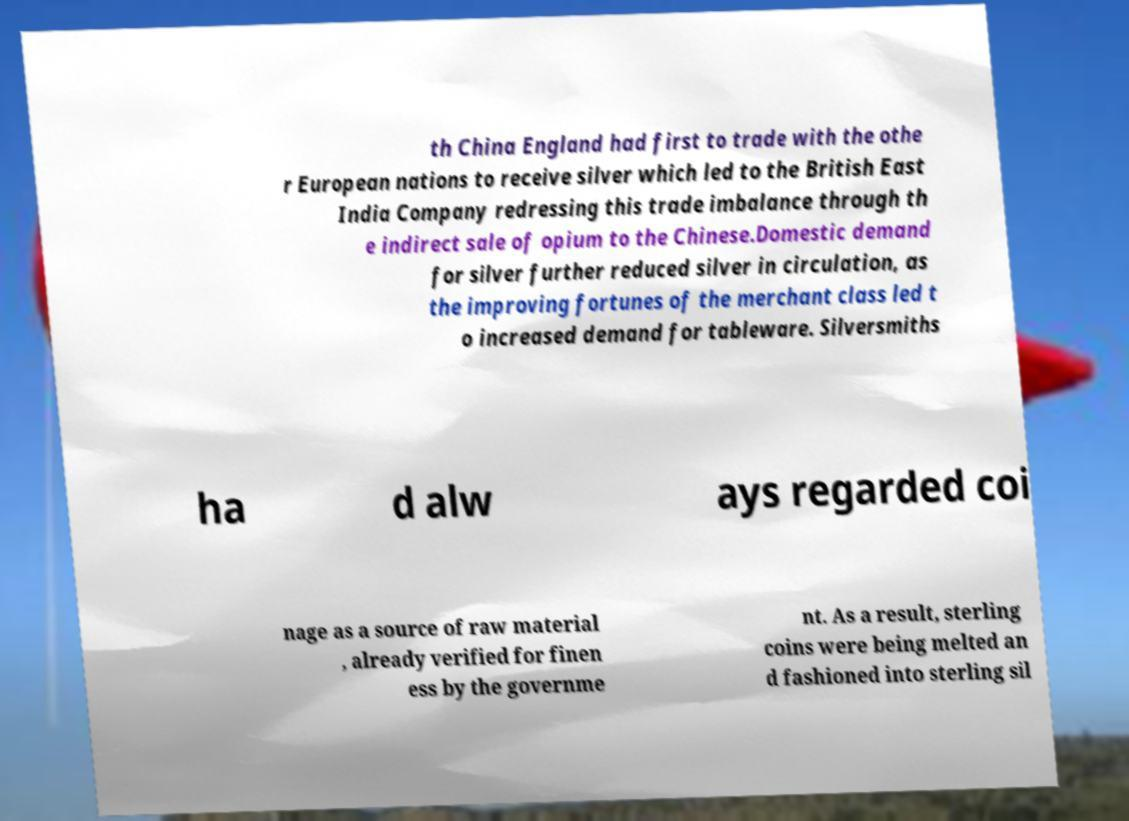What messages or text are displayed in this image? I need them in a readable, typed format. th China England had first to trade with the othe r European nations to receive silver which led to the British East India Company redressing this trade imbalance through th e indirect sale of opium to the Chinese.Domestic demand for silver further reduced silver in circulation, as the improving fortunes of the merchant class led t o increased demand for tableware. Silversmiths ha d alw ays regarded coi nage as a source of raw material , already verified for finen ess by the governme nt. As a result, sterling coins were being melted an d fashioned into sterling sil 